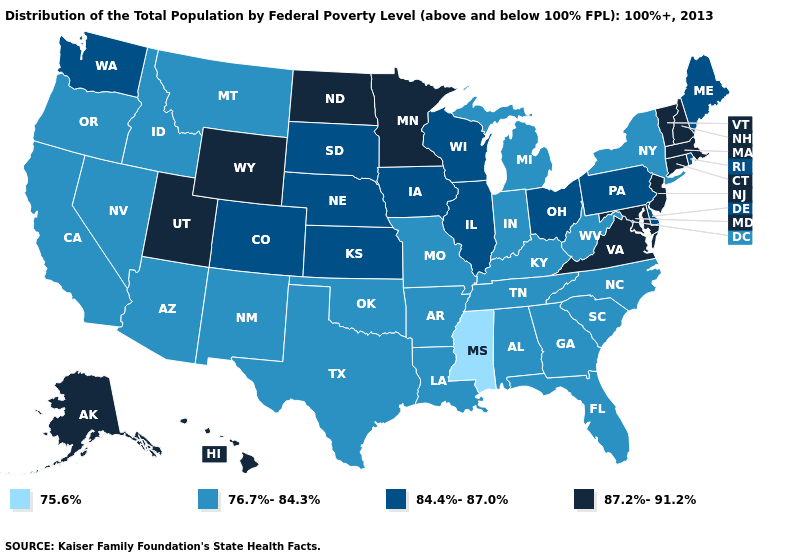What is the lowest value in states that border Tennessee?
Be succinct. 75.6%. Name the states that have a value in the range 76.7%-84.3%?
Answer briefly. Alabama, Arizona, Arkansas, California, Florida, Georgia, Idaho, Indiana, Kentucky, Louisiana, Michigan, Missouri, Montana, Nevada, New Mexico, New York, North Carolina, Oklahoma, Oregon, South Carolina, Tennessee, Texas, West Virginia. What is the value of Massachusetts?
Give a very brief answer. 87.2%-91.2%. What is the value of Mississippi?
Keep it brief. 75.6%. What is the value of South Carolina?
Short answer required. 76.7%-84.3%. Does Wyoming have a higher value than Tennessee?
Keep it brief. Yes. Does Oregon have the same value as Alabama?
Be succinct. Yes. Which states have the highest value in the USA?
Give a very brief answer. Alaska, Connecticut, Hawaii, Maryland, Massachusetts, Minnesota, New Hampshire, New Jersey, North Dakota, Utah, Vermont, Virginia, Wyoming. Name the states that have a value in the range 75.6%?
Concise answer only. Mississippi. Does Hawaii have the same value as Connecticut?
Keep it brief. Yes. What is the value of Arkansas?
Write a very short answer. 76.7%-84.3%. Name the states that have a value in the range 75.6%?
Be succinct. Mississippi. Does Maryland have the highest value in the USA?
Concise answer only. Yes. What is the lowest value in states that border North Dakota?
Concise answer only. 76.7%-84.3%. Name the states that have a value in the range 76.7%-84.3%?
Short answer required. Alabama, Arizona, Arkansas, California, Florida, Georgia, Idaho, Indiana, Kentucky, Louisiana, Michigan, Missouri, Montana, Nevada, New Mexico, New York, North Carolina, Oklahoma, Oregon, South Carolina, Tennessee, Texas, West Virginia. 